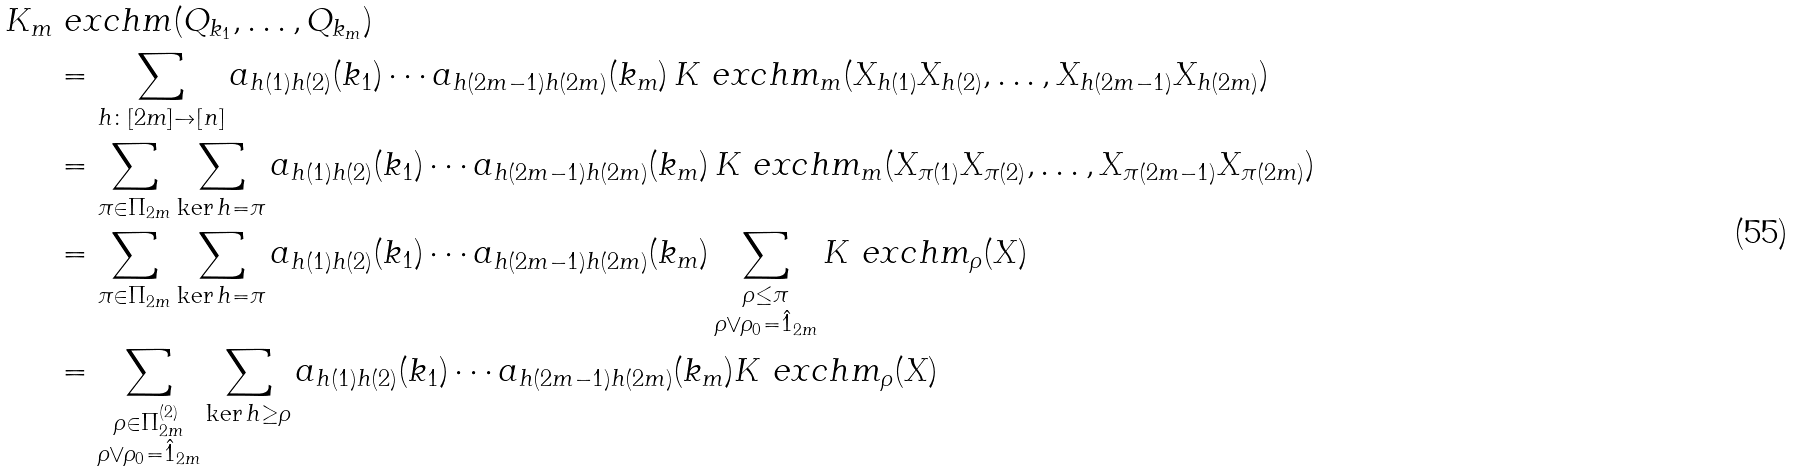<formula> <loc_0><loc_0><loc_500><loc_500>K _ { m } & \ e x c h m ( Q _ { k _ { 1 } } , \dots , Q _ { k _ { m } } ) \\ & = \sum _ { h \colon [ 2 m ] \to [ n ] } a _ { h ( 1 ) h ( 2 ) } ( k _ { 1 } ) \cdots a _ { h ( 2 m - 1 ) h ( 2 m ) } ( k _ { m } ) \, K ^ { \ } e x c h m _ { m } ( X _ { h ( 1 ) } X _ { h ( 2 ) } , \dots , X _ { h ( 2 m - 1 ) } X _ { h ( 2 m ) } ) \\ & = \sum _ { \pi \in \Pi _ { 2 m } } \sum _ { \ker h = \pi } a _ { h ( 1 ) h ( 2 ) } ( k _ { 1 } ) \cdots a _ { h ( 2 m - 1 ) h ( 2 m ) } ( k _ { m } ) \, K ^ { \ } e x c h m _ { m } ( X _ { \pi ( 1 ) } X _ { \pi ( 2 ) } , \dots , X _ { \pi ( 2 m - 1 ) } X _ { \pi ( 2 m ) } ) \\ & = \sum _ { \pi \in \Pi _ { 2 m } } \sum _ { \ker h = \pi } a _ { h ( 1 ) h ( 2 ) } ( k _ { 1 } ) \cdots a _ { h ( 2 m - 1 ) h ( 2 m ) } ( k _ { m } ) \sum _ { \substack { \rho \leq \pi \\ \rho \vee \rho _ { 0 } = \hat { 1 } _ { 2 m } } } K ^ { \ } e x c h m _ { \rho } ( X ) \\ & = \sum _ { \substack { \rho \in \Pi _ { 2 m } ^ { ( 2 ) } \\ \rho \vee \rho _ { 0 } = \hat { 1 } _ { 2 m } } } \sum _ { \ker h \geq \rho } a _ { h ( 1 ) h ( 2 ) } ( k _ { 1 } ) \cdots a _ { h ( 2 m - 1 ) h ( 2 m ) } ( k _ { m } ) K ^ { \ } e x c h m _ { \rho } ( X )</formula> 